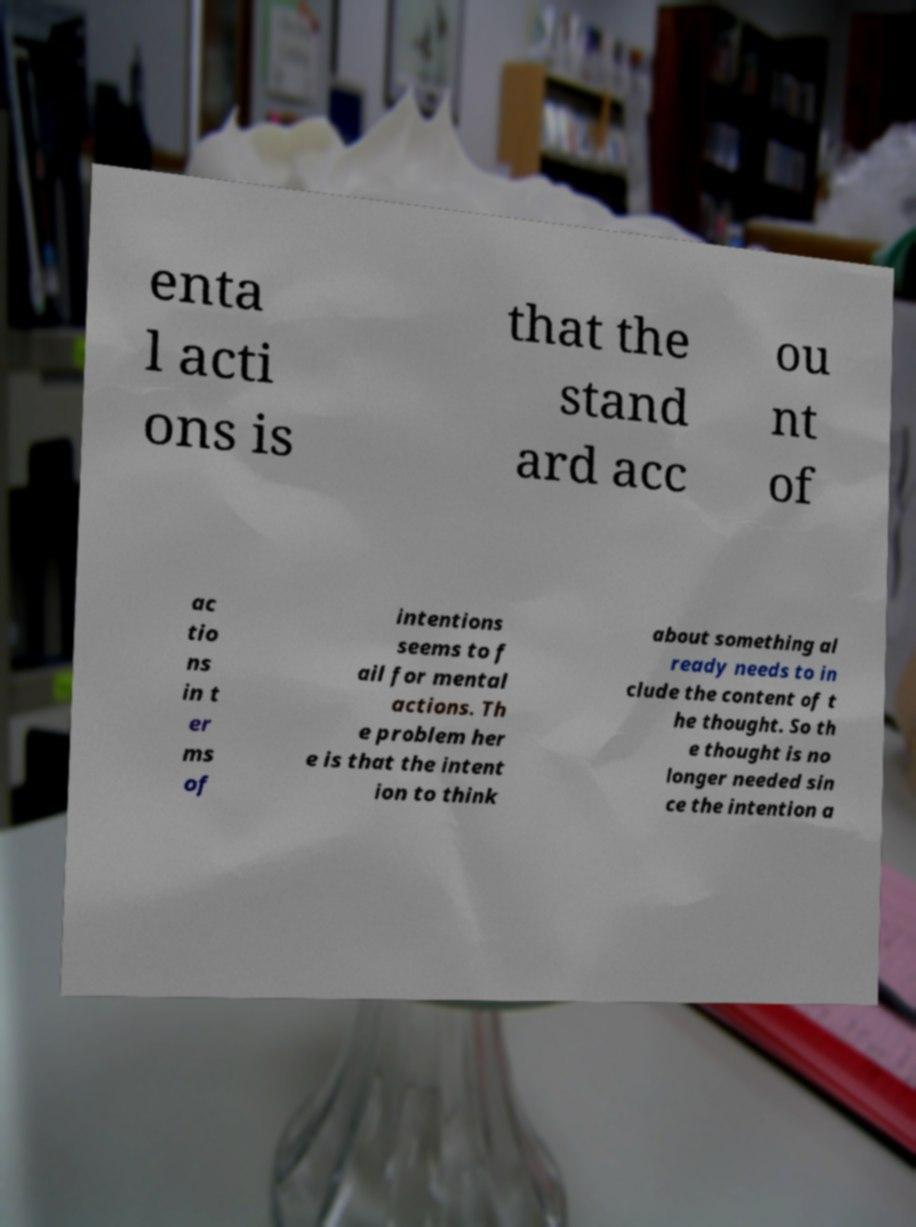For documentation purposes, I need the text within this image transcribed. Could you provide that? enta l acti ons is that the stand ard acc ou nt of ac tio ns in t er ms of intentions seems to f ail for mental actions. Th e problem her e is that the intent ion to think about something al ready needs to in clude the content of t he thought. So th e thought is no longer needed sin ce the intention a 